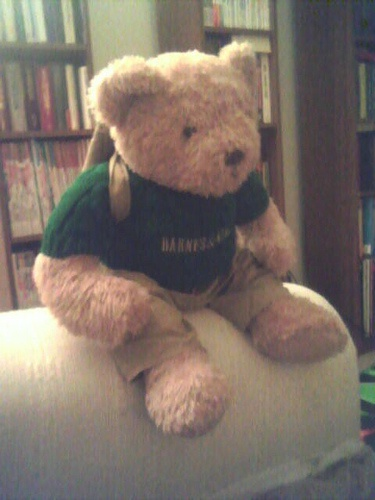Describe the objects in this image and their specific colors. I can see teddy bear in beige, gray, tan, and black tones, couch in beige and gray tones, book in beige, tan, and gray tones, book in beige and darkgray tones, and backpack in beige, gray, and tan tones in this image. 